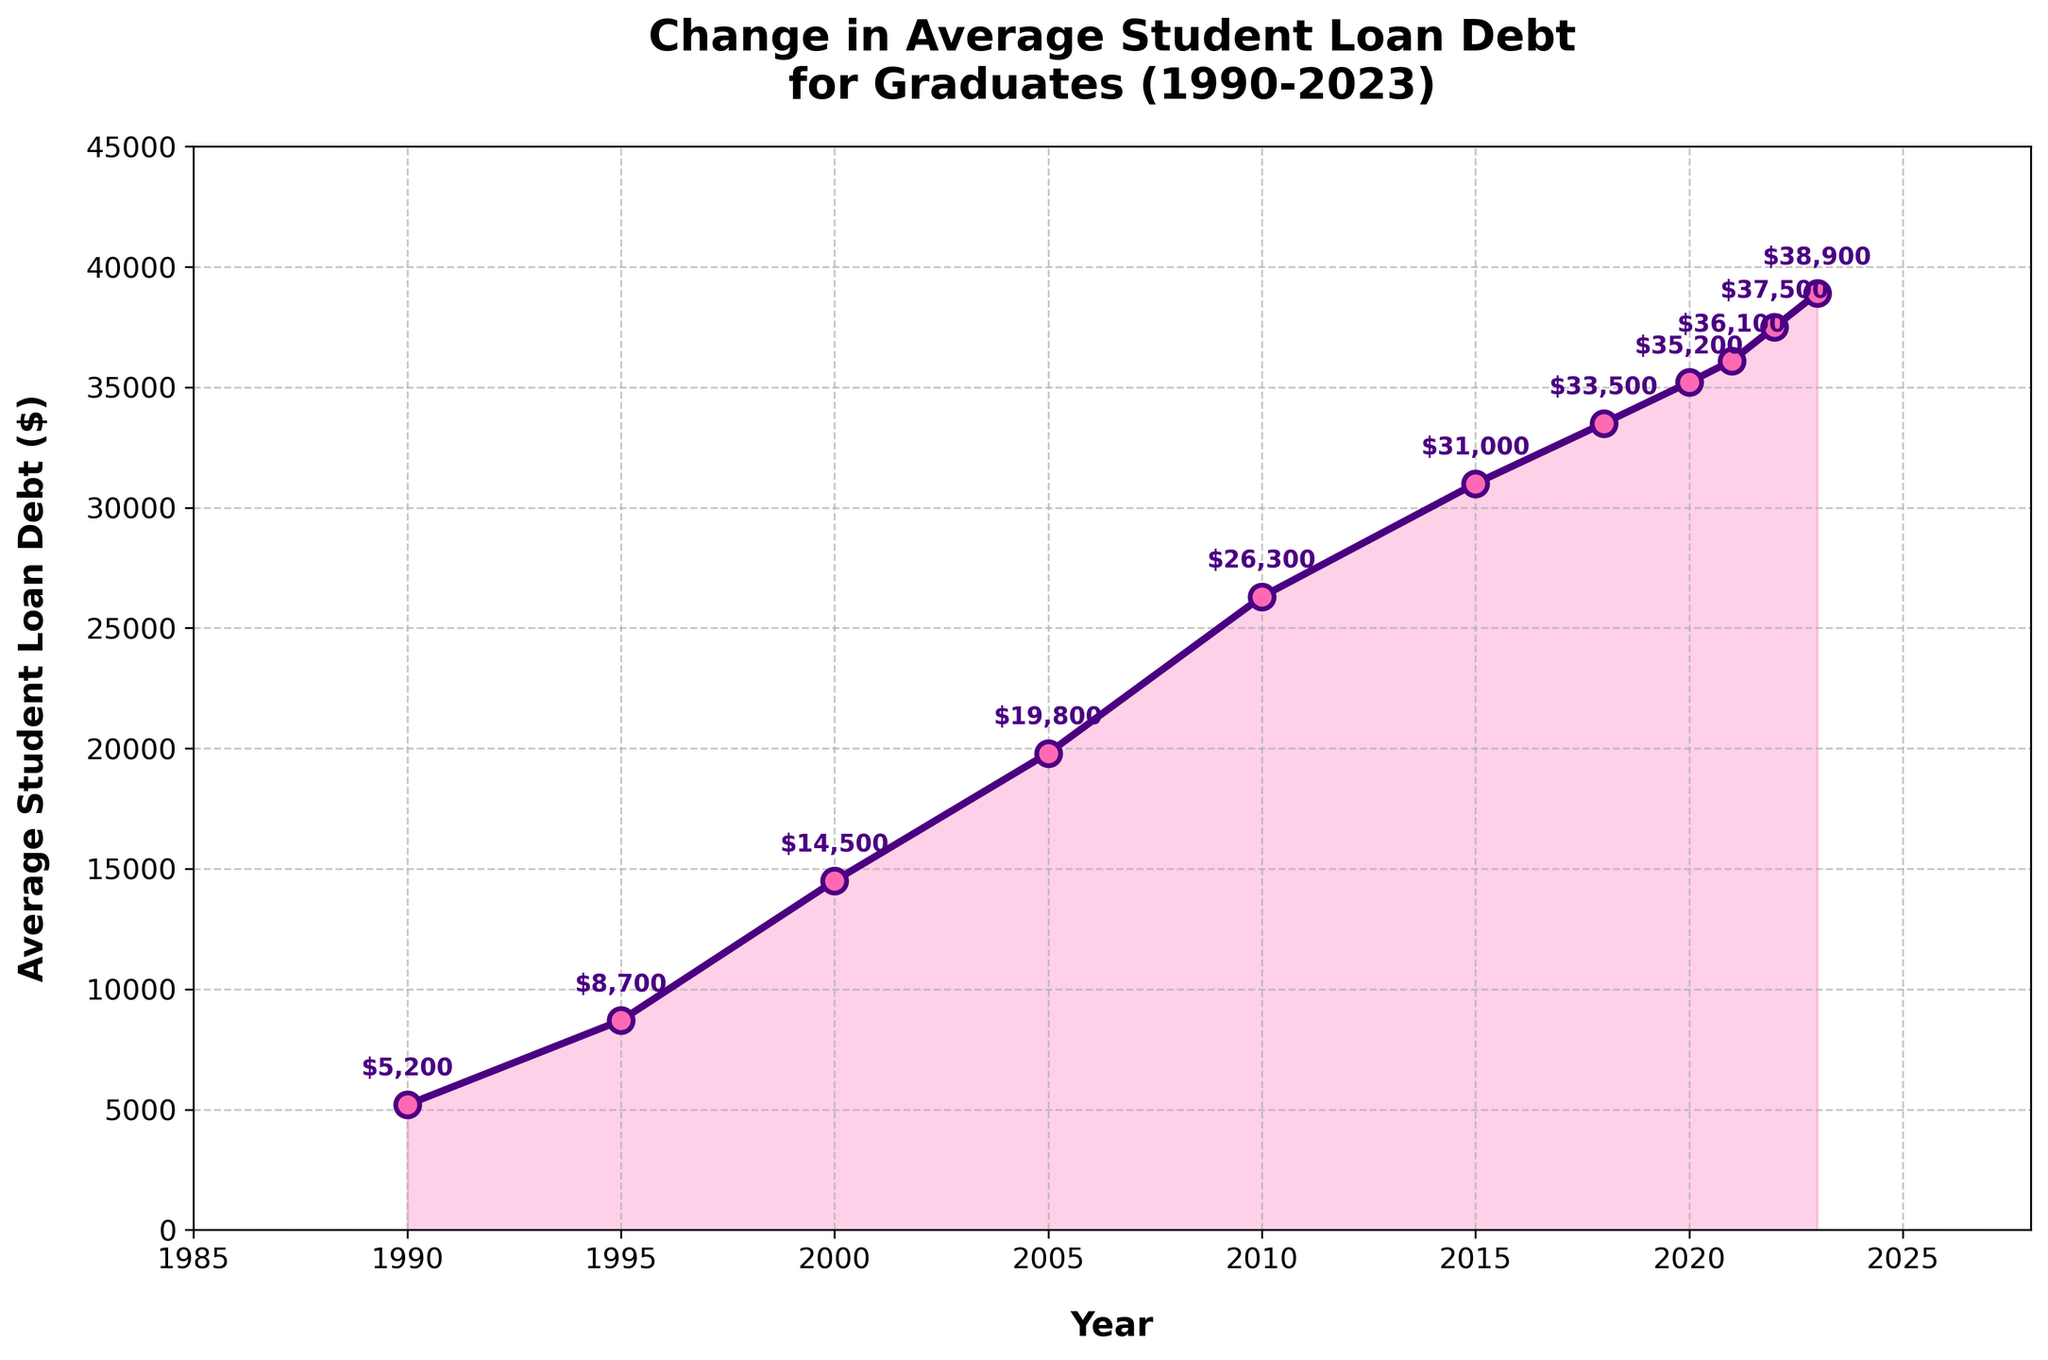What is the average student loan debt in 2005? To find the average student loan debt for a specific year, locate the year on the x-axis and then find the corresponding value on the y-axis. For 2005, the average debt is shown at $19,800.
Answer: $19,800 How much did the average student loan debt increase between 1990 and 2023? Identify the debt values for both years (1990: $5,200 and 2023: $38,900). Subtract the 1990 value from the 2023 value to find the increase: $38,900 - $5,200 = $33,700.
Answer: $33,700 In which year did the average student loan debt surpass $15,000? Look at the points on the chart where the debt value exceeds $15,000. The first year this happens is 2000.
Answer: 2000 Compare the average student loan debt in 2010 to the debt in 2015. Which year had a higher debt? Identify the debt values for both years (2010: $26,300 and 2015: $31,000). Compare the two values: $31,000 > $26,300, so 2015 had a higher average debt.
Answer: 2015 What is the biggest year-to-year increase in average student loan debt? Calculate the differences between consecutive years and determine the largest difference. 1990-1995: $3,500, 1995-2000: $5,800, 2000-2005: $5,300, 2005-2010: $6,500, 2010-2015: $4,700, 2015-2018: $2,500, 2018-2020: $1,700, 2020-2021: $900, 2021-2022: $1,400, 2022-2023: $1,400. The largest increase is between 2005 and 2010 ($6,500).
Answer: $6,500 By how much did the average student loan debt change from 2021 to 2023? Subtract the debt value in 2021 ($36,100) from the value in 2023 ($38,900): $38,900 - $36,100 = $2,800.
Answer: $2,800 Which year saw the smallest increase in average student loan debt compared to the previous year? Compare the year-to-year increases calculated previously: 1990-1995: $3,500, 1995-2000: $5,800, 2000-2005: $5,300, 2005-2010: $6,500, 2010-2015: $4,700, 2015-2018: $2,500, 2018-2020: $1,700, 2020-2021: $900, 2021-2022: $1,400, 2022-2023: $1,400. The smallest increase is $900 in 2020-2021.
Answer: 2020-2021 What is the visual representation used to highlight the area under the average student loan debt curve? Observing the plot, the area under the curve is shaded or filled with a color to visually emphasize it.
Answer: Shaded area Is there any year when the average student loan debt declined compared to the previous year? Evaluate the chart to see if any year shows a downward trend compared to the prior year. The plot shows a consistent upward trend with no declines.
Answer: No Which year shows the sharpest upward trend visually? Examine the line for the steepest slope. The sharpest visual increase occurs between 2005 and 2010.
Answer: 2005-2010 